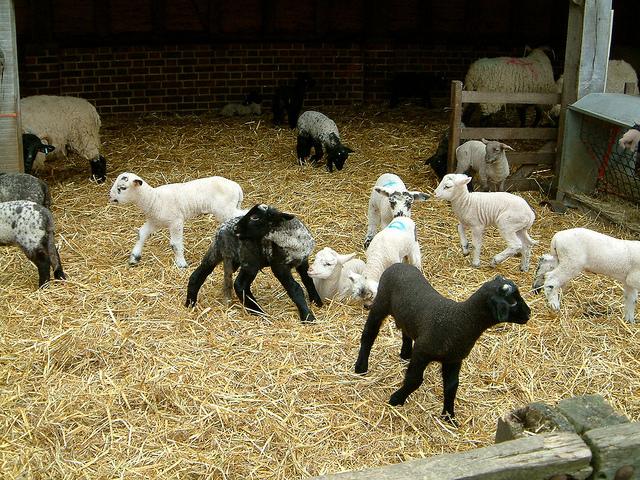How many black lambs?
Give a very brief answer. 3. How many white lambs are there?
Short answer required. 6. Are the lambs eating?
Answer briefly. No. 